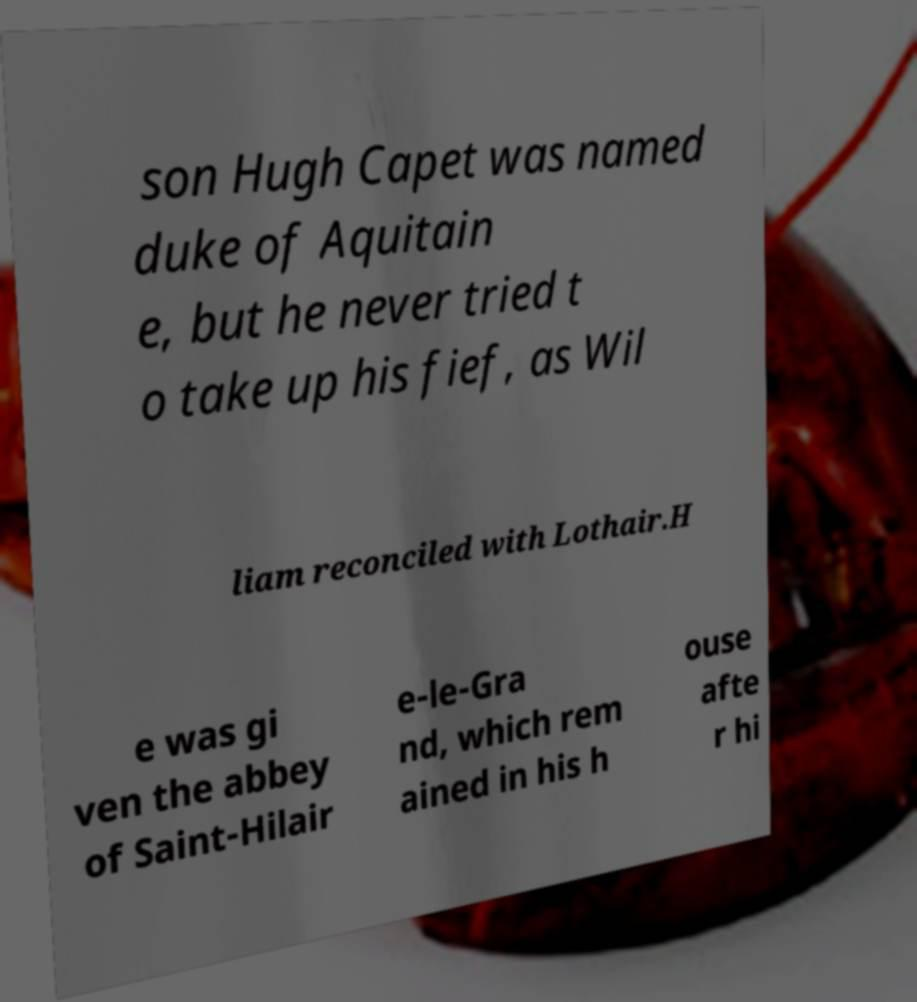Please identify and transcribe the text found in this image. son Hugh Capet was named duke of Aquitain e, but he never tried t o take up his fief, as Wil liam reconciled with Lothair.H e was gi ven the abbey of Saint-Hilair e-le-Gra nd, which rem ained in his h ouse afte r hi 